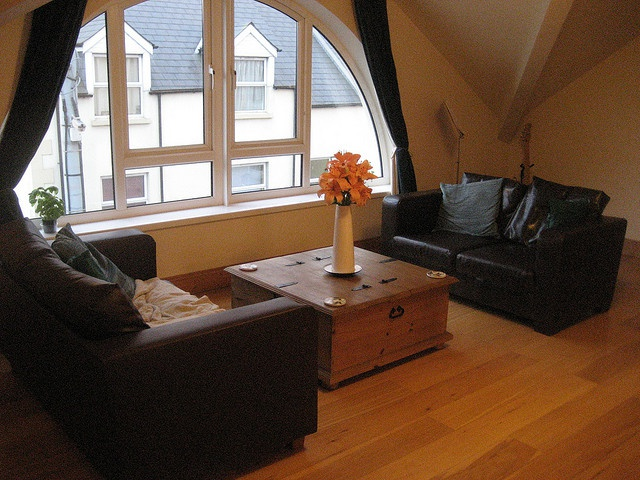Describe the objects in this image and their specific colors. I can see couch in maroon, black, gray, and darkgray tones, couch in maroon, black, gray, and darkgray tones, couch in maroon, black, gray, and purple tones, vase in maroon, olive, gray, black, and darkgray tones, and potted plant in maroon, gray, darkgreen, white, and darkgray tones in this image. 